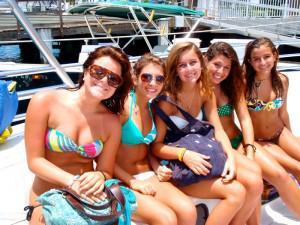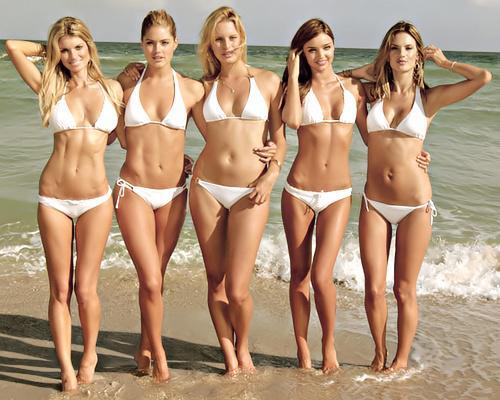The first image is the image on the left, the second image is the image on the right. Considering the images on both sides, is "At least 2 girls are wearing sunglasses." valid? Answer yes or no. Yes. The first image is the image on the left, the second image is the image on the right. Considering the images on both sides, is "The women in the image on the right are standing at least up to their knees in the water." valid? Answer yes or no. No. 